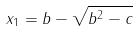<formula> <loc_0><loc_0><loc_500><loc_500>x _ { 1 } = b - \sqrt { b ^ { 2 } - c }</formula> 